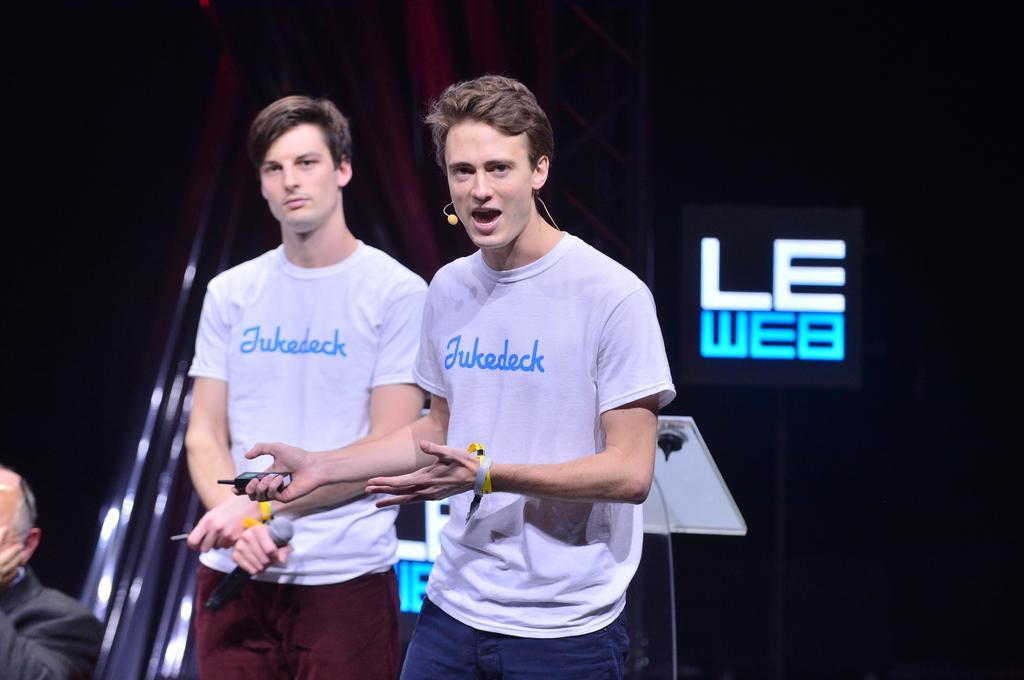Can you describe this image briefly? In this image I can see two persons wearing white colored t shirts, blue pant and brown pant are standing and holding few objects in their hands. In the background I can see a person sitting, a black colored board, the red colored curtain and the dark background. 